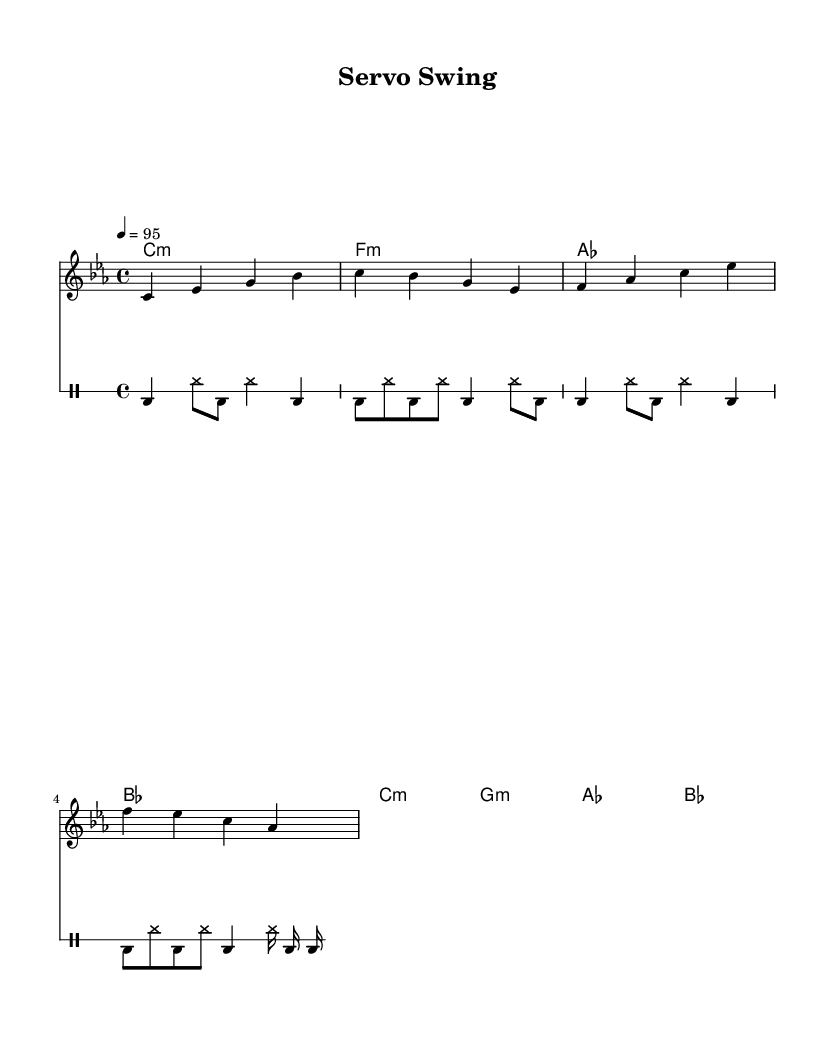What is the key signature of this music? The key signature indicated at the beginning of the score is C minor, which contains three flats (B flat, E flat, and A flat).
Answer: C minor What is the time signature of this music? The time signature shown in the score is 4/4, meaning there are four beats in each measure and the quarter note receives one beat.
Answer: 4/4 What is the tempo marking for this piece? The tempo marking at the beginning states that the piece should be played at quarter note equals 95 beats per minute, indicating a moderate pace.
Answer: 95 How many measures are there in the melody? The melody consists of four measures, as indicated by the notation on the score, with each line representing a complete measure.
Answer: 4 What type of musical form is used in this rap piece? The structure of the music corresponds to a typical verse-chorus form found in rap, which is characterized by repeated rhythmic and melodic patterns.
Answer: Verse-chorus What is the rhythmic pattern in the drum line? The drum line features a repeated pattern of bass drum and hi-hat combinations, showcasing a strong urban beat typical in rap music, emphasizing various syncopations.
Answer: Urban beat Which chords are played in the harmony? The harmony consists of the following chords: C minor, F minor, A flat major, and B flat major, which create a rich harmonic background supporting the melody.
Answer: C minor, F minor, A flat, B flat 